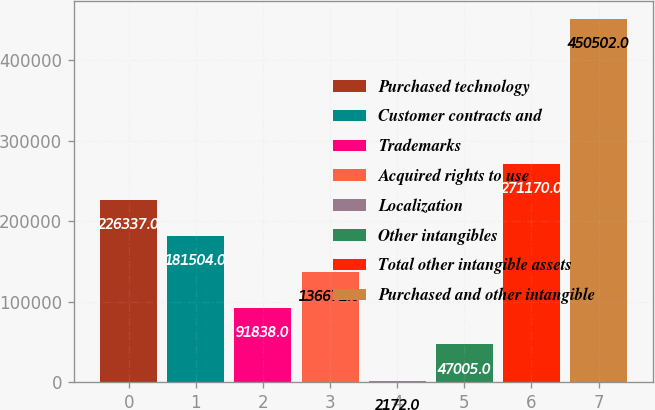<chart> <loc_0><loc_0><loc_500><loc_500><bar_chart><fcel>Purchased technology<fcel>Customer contracts and<fcel>Trademarks<fcel>Acquired rights to use<fcel>Localization<fcel>Other intangibles<fcel>Total other intangible assets<fcel>Purchased and other intangible<nl><fcel>226337<fcel>181504<fcel>91838<fcel>136671<fcel>2172<fcel>47005<fcel>271170<fcel>450502<nl></chart> 